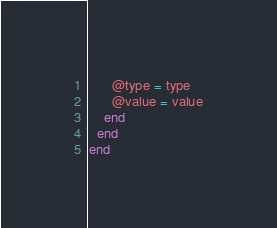Convert code to text. <code><loc_0><loc_0><loc_500><loc_500><_Ruby_>      @type = type
      @value = value
    end
  end
end
</code> 